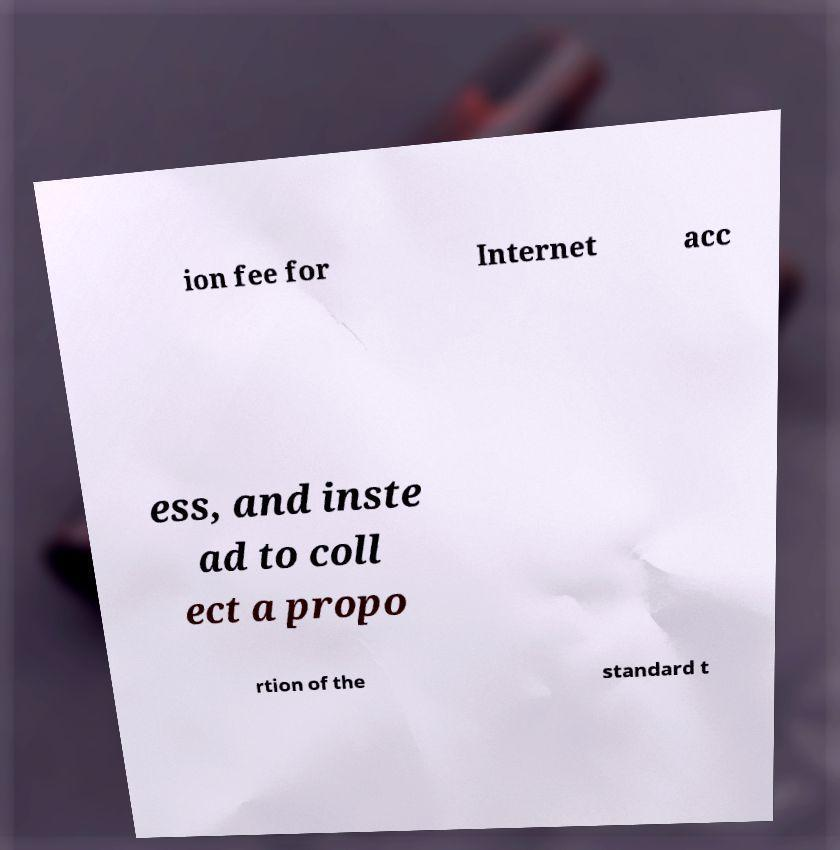For documentation purposes, I need the text within this image transcribed. Could you provide that? ion fee for Internet acc ess, and inste ad to coll ect a propo rtion of the standard t 